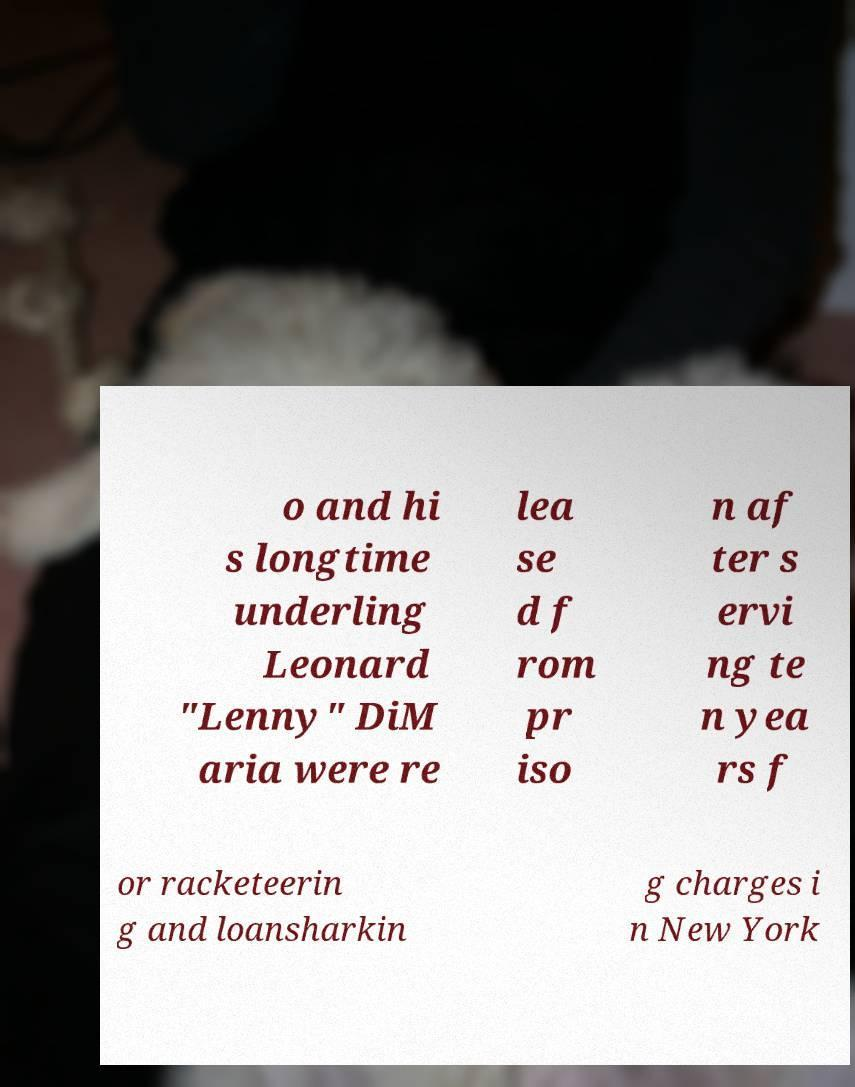Can you accurately transcribe the text from the provided image for me? o and hi s longtime underling Leonard "Lenny" DiM aria were re lea se d f rom pr iso n af ter s ervi ng te n yea rs f or racketeerin g and loansharkin g charges i n New York 